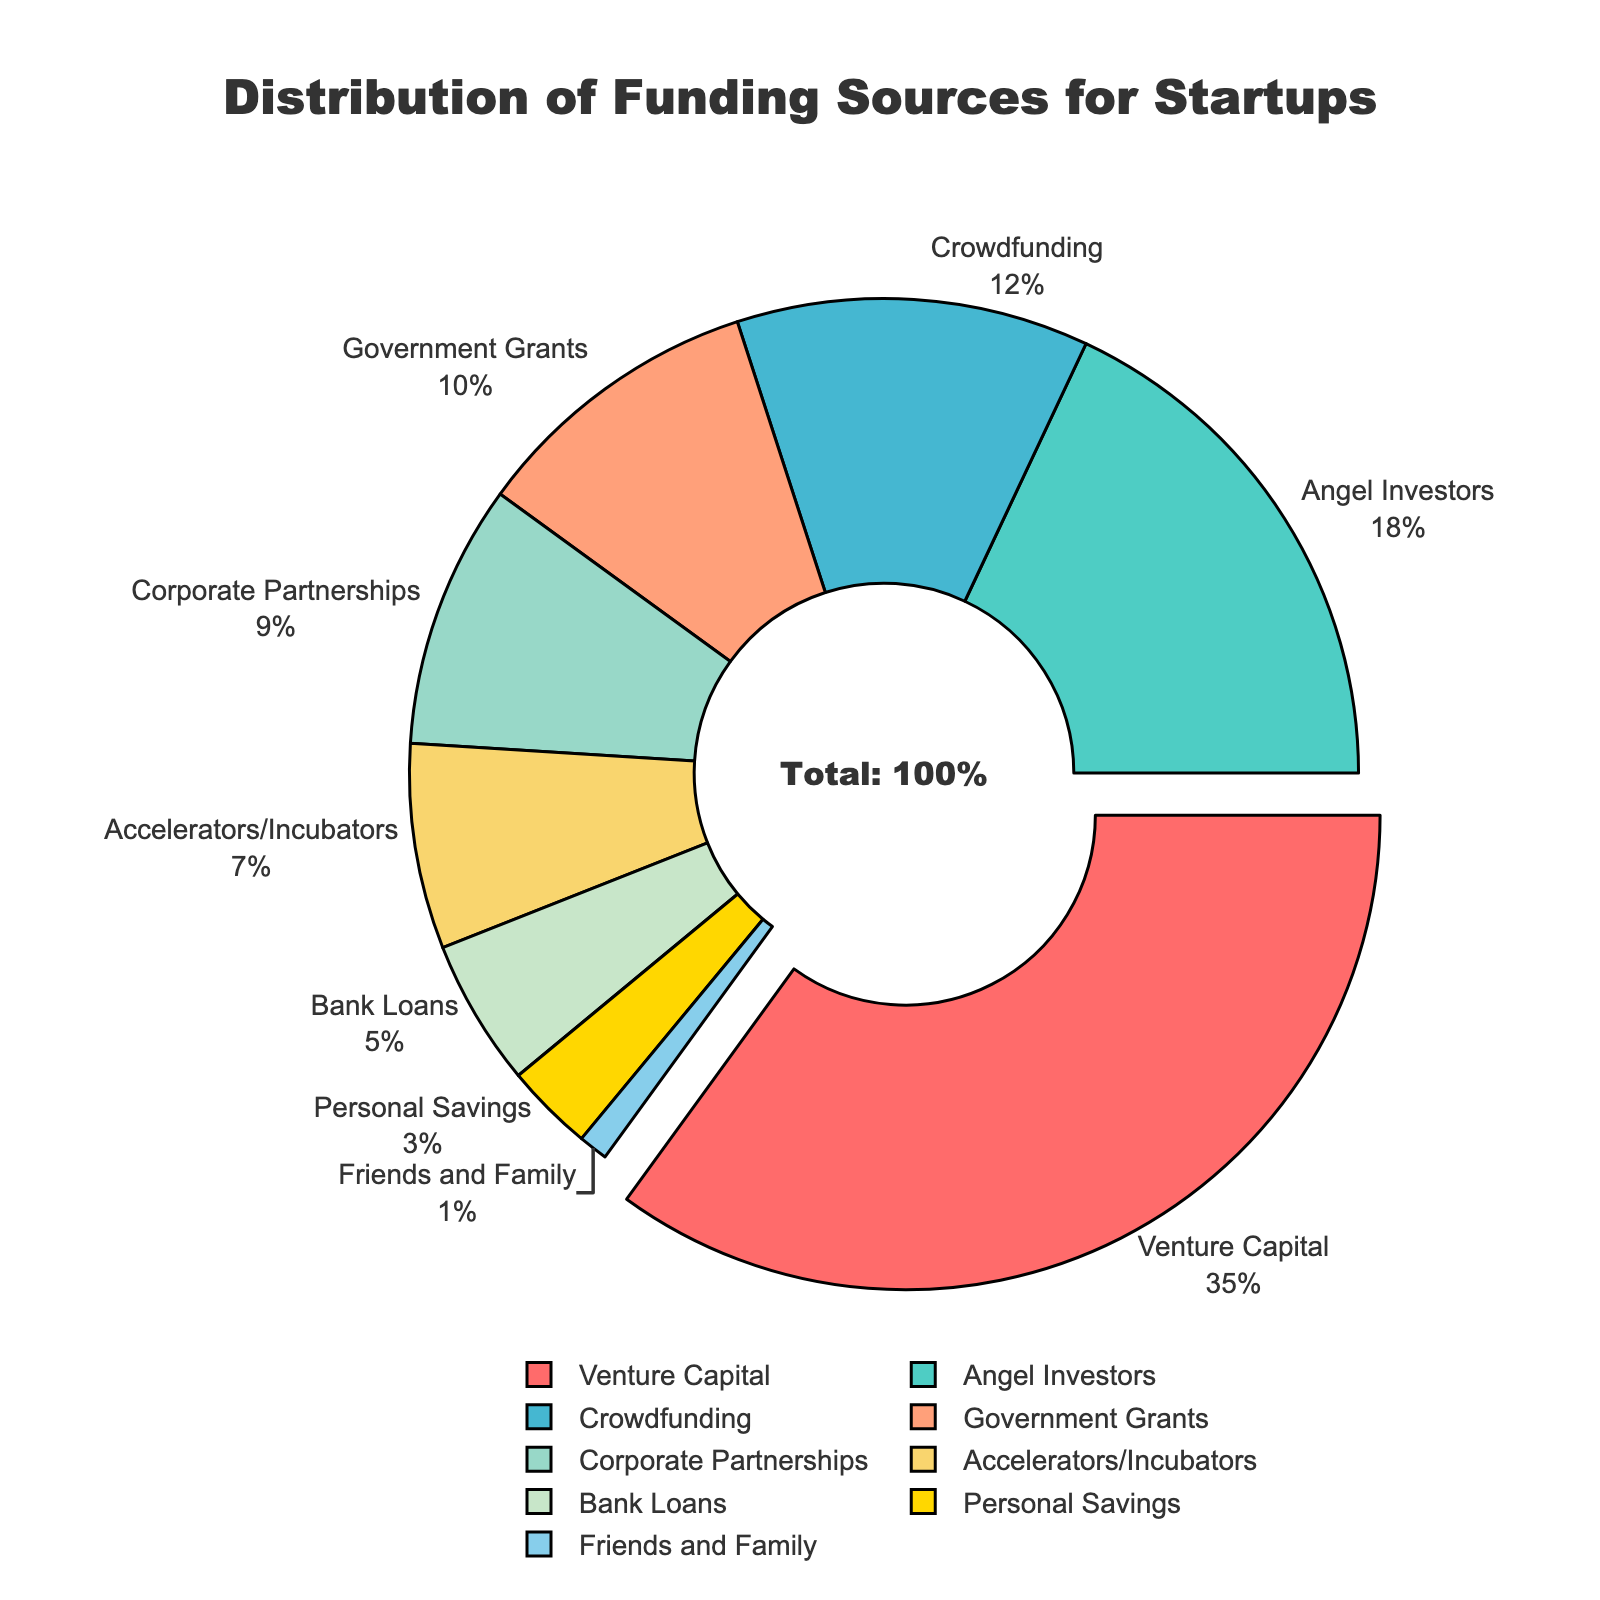What are the top three funding sources for startups in terms of percentage? The top three funding sources can be identified by looking at the pie chart segments with the largest percentages. These are Venture Capital (35%), Angel Investors (18%), and Crowdfunding (12%).
Answer: Venture Capital, Angel Investors, Crowdfunding Which funding source contributes more: Government Grants or Corporate Partnerships? Compare the percentages of Government Grants (10%) and Corporate Partnerships (9%). Government Grants have a higher percentage.
Answer: Government Grants What is the total percentage contribution of Corporate Partnerships, Accelerators/Incubators, and Bank Loans combined? Add the percentages of Corporate Partnerships (9%), Accelerators/Incubators (7%), and Bank Loans (5%). 9 + 7 + 5 = 21%
Answer: 21% What is the smallest funding source and what percentage does it represent? Identify the smallest segment in the pie chart which is Friends and Family, representing 1%.
Answer: Friends and Family, 1% How much higher in percentage is Angel Investors funding compared to Bank Loans? Subtract the percentage of Bank Loans (5%) from Angel Investors (18%). 18 - 5 = 13%
Answer: 13% What color represents Crowdfunding in the pie chart? The pie chart uses specific colors to represent each segment. Crowdfunding is represented in a shade of light blue/sky blue (#45B7D1).
Answer: Sky blue Is the percentage contribution of Personal Savings greater than the combined contribution of Friends and Family and Bank Loans? Calculate the total percentage for Friends and Family (1%) and Bank Loans (5%). 1 + 5 = 6%. Compare this with Personal Savings (3%). Personal Savings (3%) is less than the combined 6%.
Answer: No What is the difference in percentage contribution between the largest and the smallest funding sources? Subtract the smallest percentage (Friends and Family: 1%) from the largest percentage (Venture Capital: 35%). 35 - 1 = 34%
Answer: 34% Which funding source has the largest segment and what unique visual feature does it possess? The largest segment in the pie chart is Venture Capital (35%), which is visually distinguished by being slightly pulled out from the center.
Answer: Venture Capital, pulled out Is the combined percentage of Venture Capital and Angel Investors greater than half of the total funding? Calculate the combined percentage of Venture Capital (35%) and Angel Investors (18%). 35 + 18 = 53%. Compare this with half of the total funding (50%). 53% is greater than 50%.
Answer: Yes 